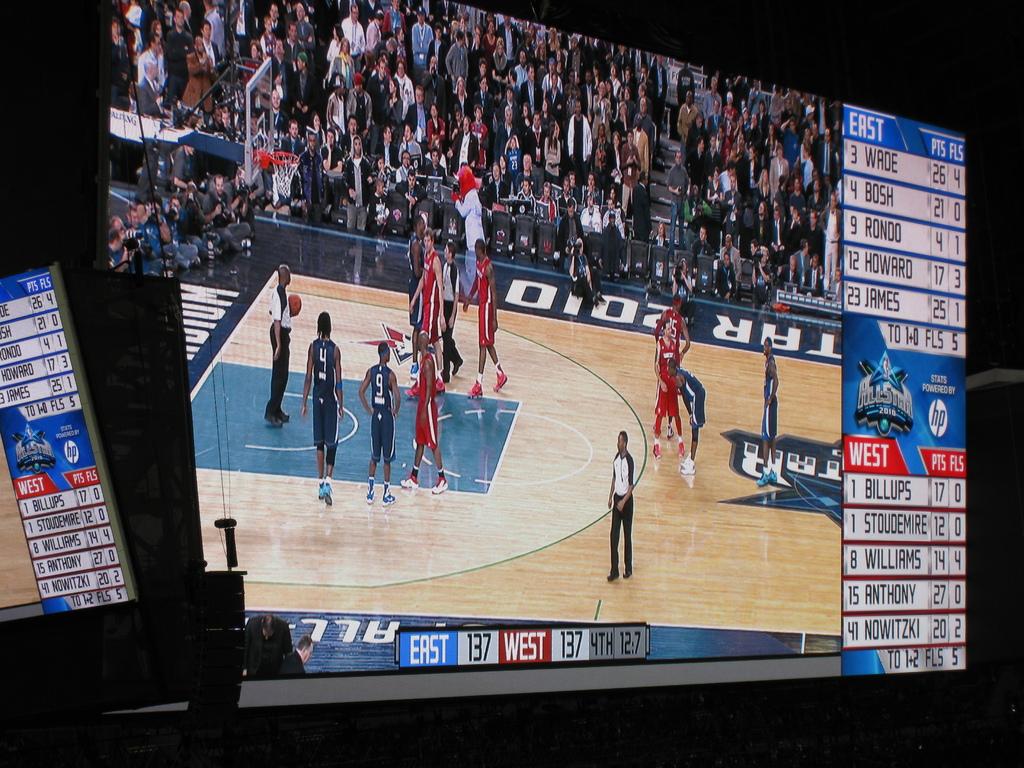What division is the blue team?
Give a very brief answer. East. Which teams are playing?
Provide a succinct answer. East and west. 